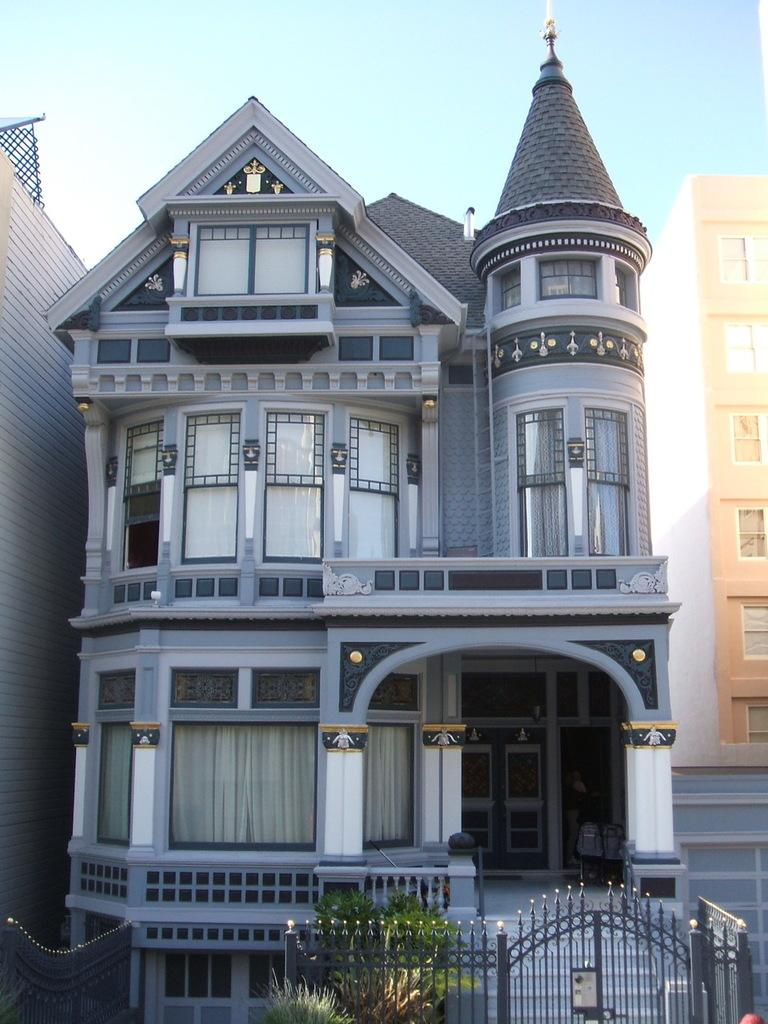What type of structures can be seen in the image? There are buildings in the image. What is visible at the top of the image? The sky is visible at the top of the image. What type of vegetation is at the bottom of the image? There are plants at the bottom of the image. What architectural feature is present in the image? There is a gate in the image. What feature allows for vertical movement within the buildings? There are staircases in the image. What type of bottle is being used in the process depicted in the image? There is no bottle or process present in the image. 